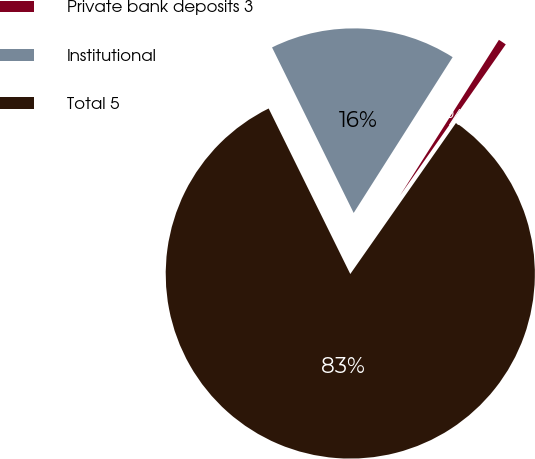<chart> <loc_0><loc_0><loc_500><loc_500><pie_chart><fcel>Private bank deposits 3<fcel>Institutional<fcel>Total 5<nl><fcel>0.71%<fcel>16.3%<fcel>82.99%<nl></chart> 